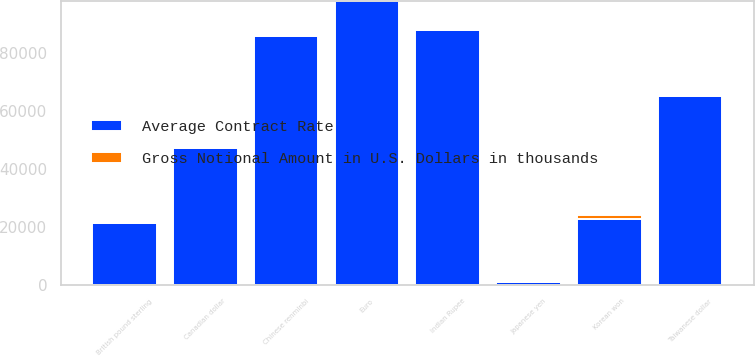Convert chart. <chart><loc_0><loc_0><loc_500><loc_500><stacked_bar_chart><ecel><fcel>Japanese yen<fcel>Euro<fcel>Chinese renminbi<fcel>Taiwanese dollar<fcel>Indian Rupee<fcel>Canadian dollar<fcel>Korean won<fcel>British pound sterling<nl><fcel>Average Contract Rate<fcel>1121.11<fcel>98121<fcel>86154<fcel>65367<fcel>88192<fcel>47451<fcel>22869<fcel>21260<nl><fcel>Gross Notional Amount in U.S. Dollars in thousands<fcel>107.89<fcel>0.89<fcel>6.78<fcel>32.13<fcel>70.22<fcel>1.32<fcel>1121.11<fcel>0.71<nl></chart> 